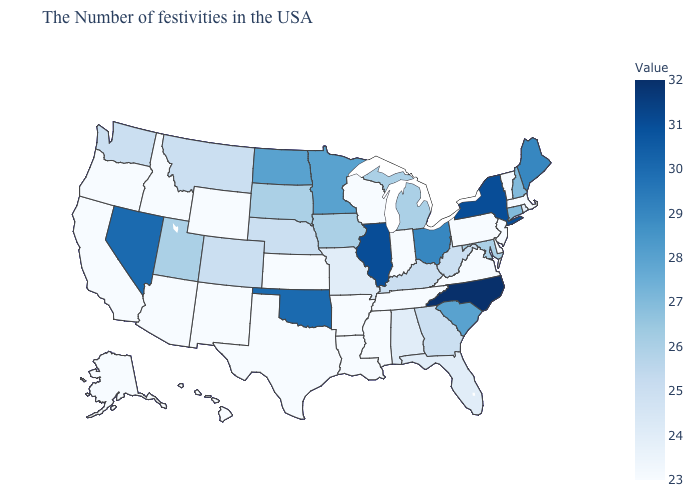Which states hav the highest value in the South?
Keep it brief. North Carolina. Among the states that border South Carolina , which have the lowest value?
Concise answer only. Georgia. Which states have the lowest value in the USA?
Quick response, please. Massachusetts, Vermont, New Jersey, Delaware, Pennsylvania, Virginia, Indiana, Tennessee, Wisconsin, Mississippi, Louisiana, Arkansas, Kansas, Texas, Wyoming, New Mexico, Arizona, Idaho, California, Oregon, Alaska, Hawaii. Which states hav the highest value in the MidWest?
Write a very short answer. Illinois. Does Florida have a higher value than North Dakota?
Quick response, please. No. 